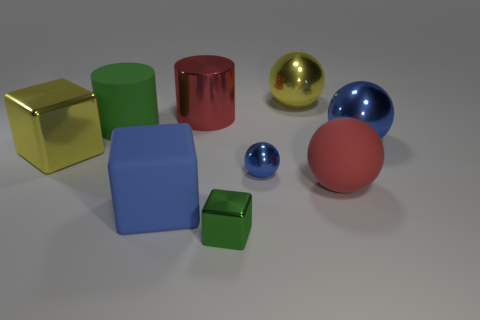What size is the ball that is the same color as the shiny cylinder?
Make the answer very short. Large. What is the size of the metallic object that is to the right of the tiny blue sphere and behind the matte cylinder?
Ensure brevity in your answer.  Large. What is the size of the green thing that is in front of the large red rubber sphere?
Keep it short and to the point. Small. There is a large metallic thing that is the same color as the matte sphere; what is its shape?
Offer a very short reply. Cylinder. There is a green object that is to the left of the big red cylinder that is right of the block left of the blue rubber thing; what shape is it?
Your answer should be compact. Cylinder. What number of other things are there of the same shape as the tiny green thing?
Provide a succinct answer. 2. What number of metal things are either small green blocks or large blue balls?
Your answer should be compact. 2. What material is the big blue object on the left side of the shiny sphere right of the red sphere?
Offer a terse response. Rubber. Is the number of rubber objects that are behind the red shiny cylinder greater than the number of brown rubber balls?
Your answer should be compact. No. Are there any tiny green things made of the same material as the small blue object?
Give a very brief answer. Yes. 